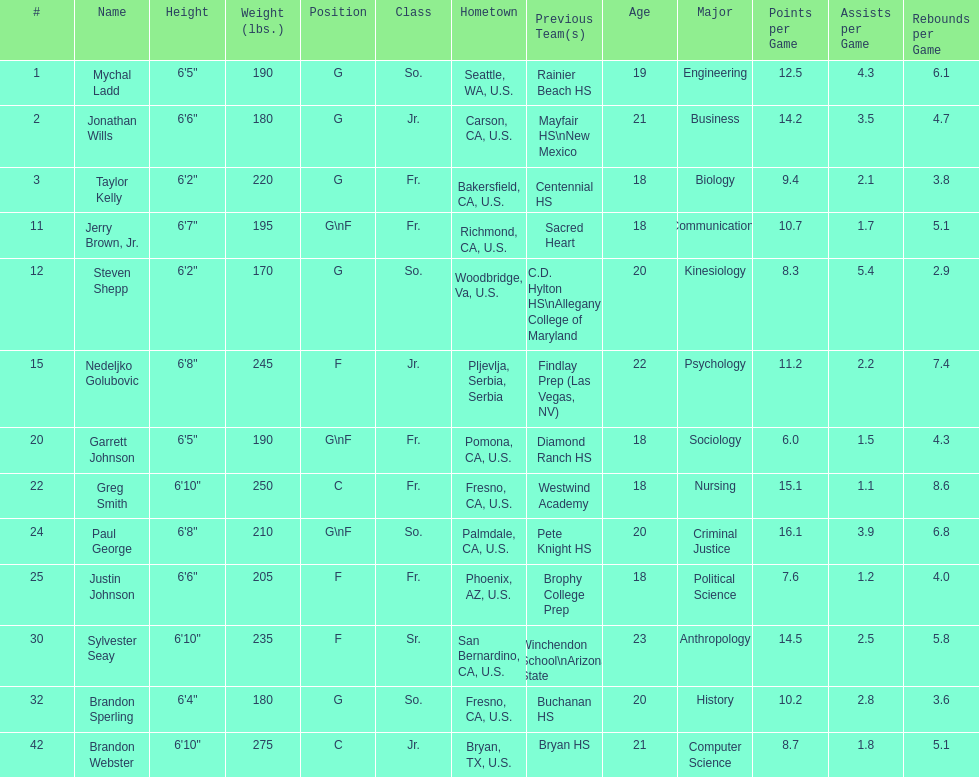How many players and both guard (g) and forward (f)? 3. 